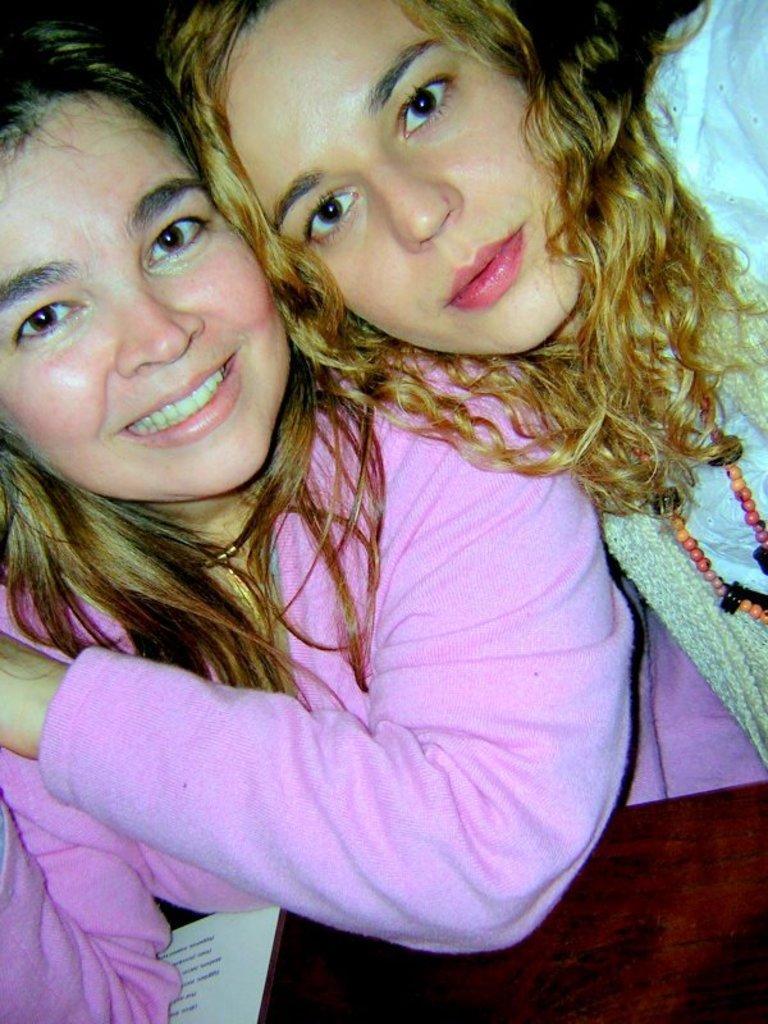In one or two sentences, can you explain what this image depicts? In this image we can see two ladies. At the bottom there is a table and we can see a paper placed on the table. 